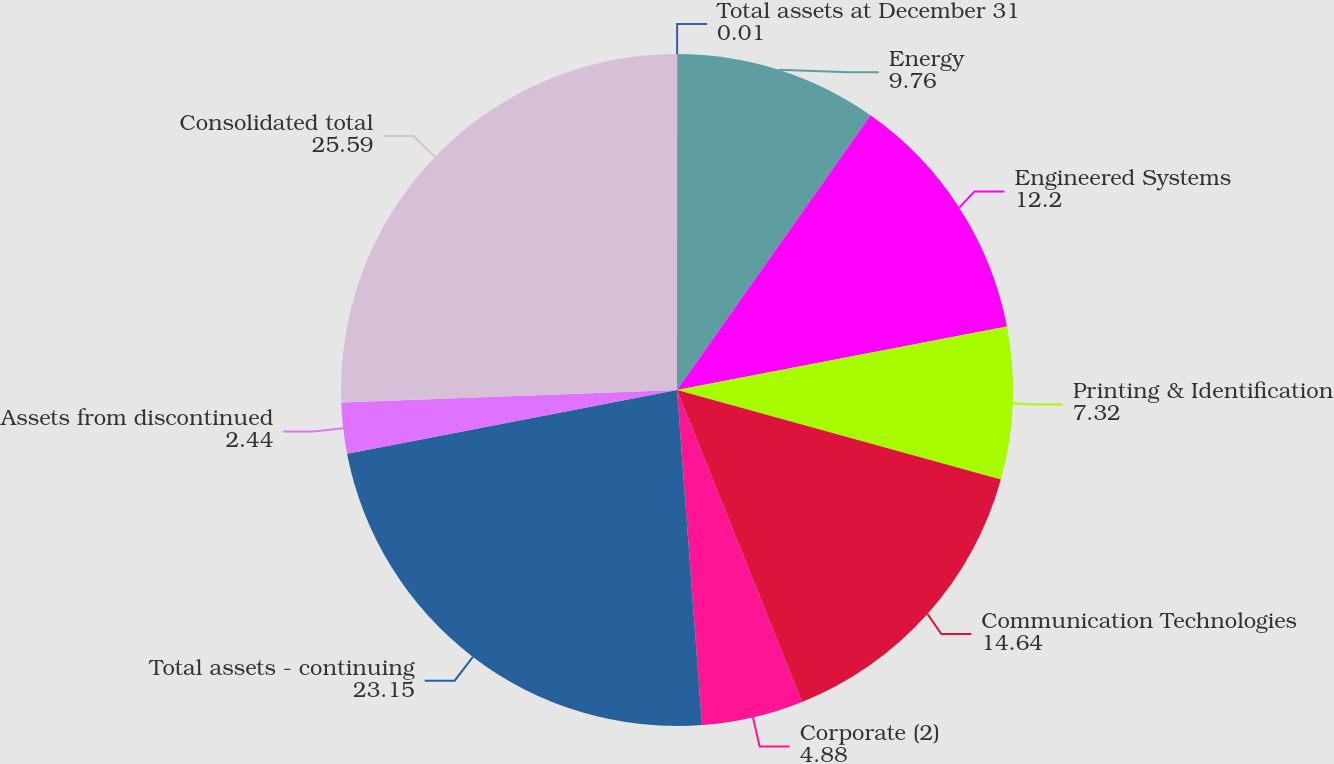Convert chart to OTSL. <chart><loc_0><loc_0><loc_500><loc_500><pie_chart><fcel>Total assets at December 31<fcel>Energy<fcel>Engineered Systems<fcel>Printing & Identification<fcel>Communication Technologies<fcel>Corporate (2)<fcel>Total assets - continuing<fcel>Assets from discontinued<fcel>Consolidated total<nl><fcel>0.01%<fcel>9.76%<fcel>12.2%<fcel>7.32%<fcel>14.64%<fcel>4.88%<fcel>23.15%<fcel>2.44%<fcel>25.59%<nl></chart> 